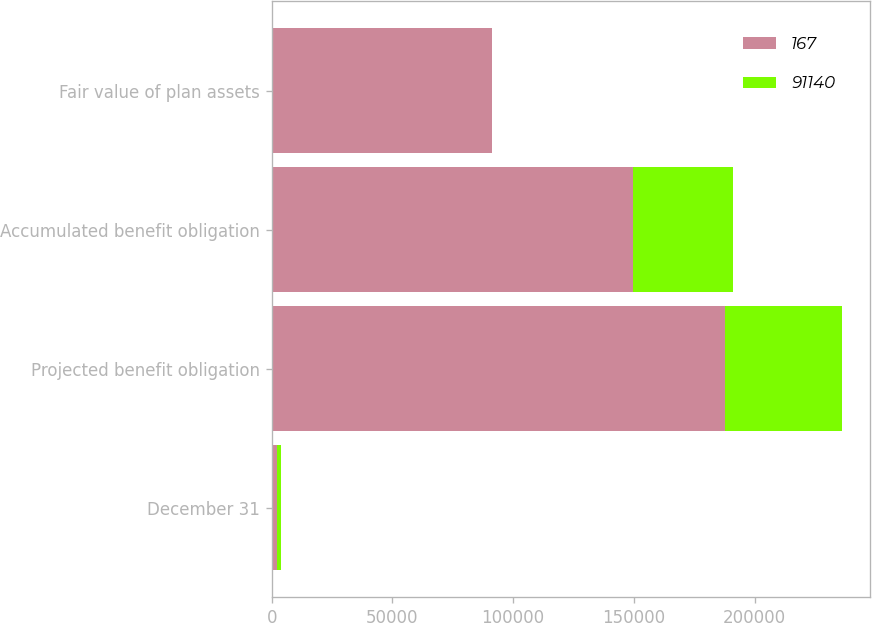Convert chart. <chart><loc_0><loc_0><loc_500><loc_500><stacked_bar_chart><ecel><fcel>December 31<fcel>Projected benefit obligation<fcel>Accumulated benefit obligation<fcel>Fair value of plan assets<nl><fcel>167<fcel>2005<fcel>187911<fcel>149840<fcel>91140<nl><fcel>91140<fcel>2004<fcel>48178<fcel>41366<fcel>167<nl></chart> 